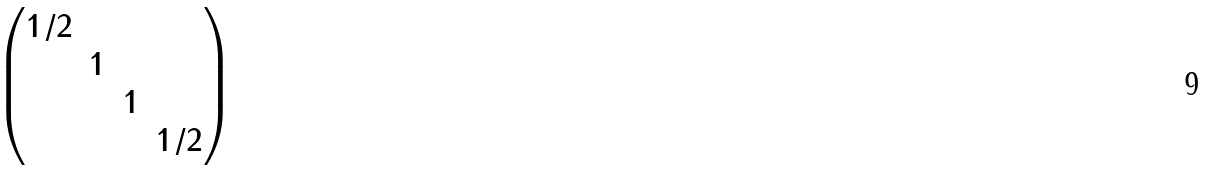<formula> <loc_0><loc_0><loc_500><loc_500>\begin{pmatrix} 1 / 2 & & & \\ & 1 & & \\ & & 1 & \\ & & & 1 / 2 \end{pmatrix}</formula> 